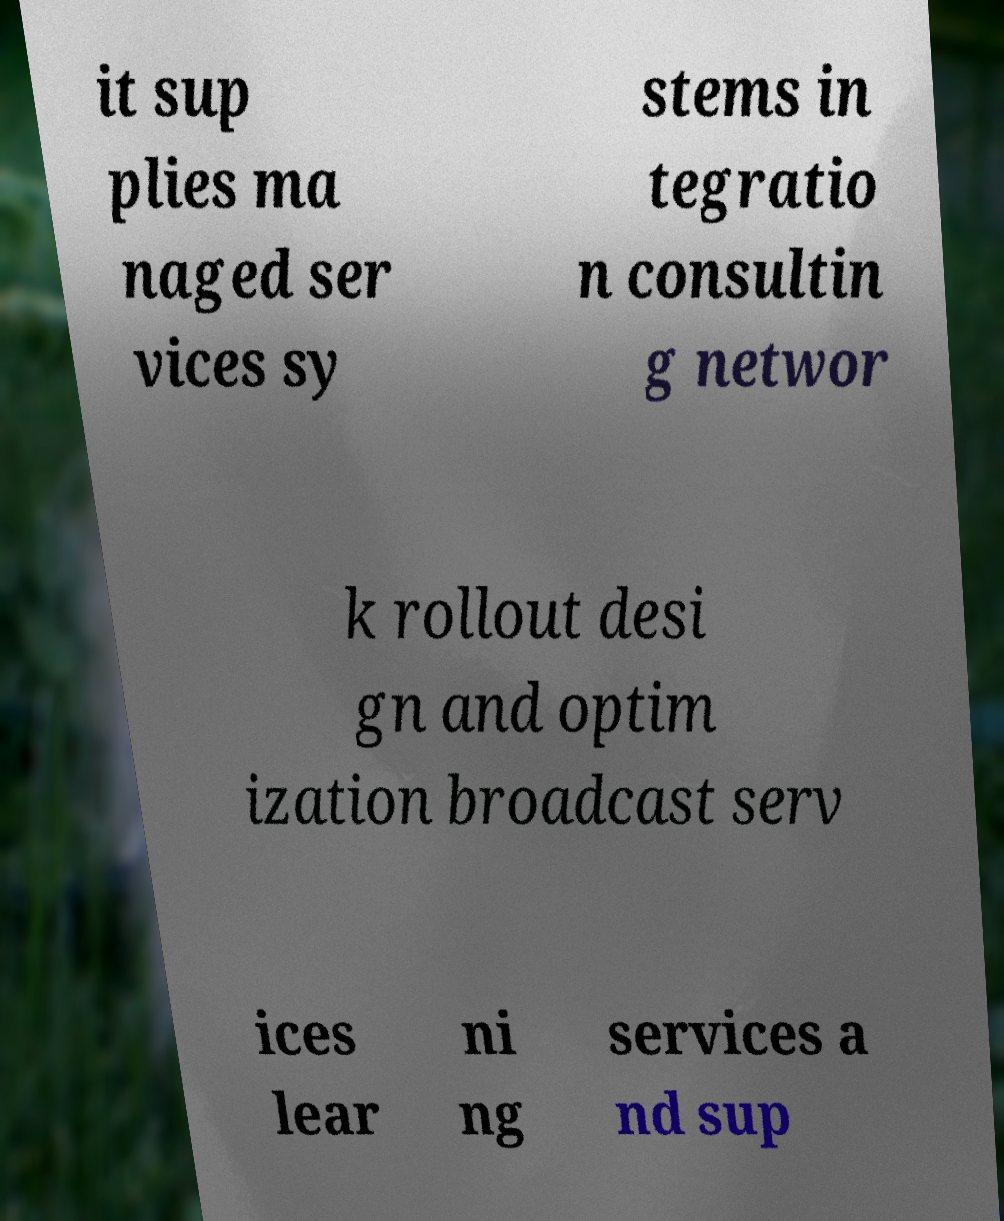Could you extract and type out the text from this image? it sup plies ma naged ser vices sy stems in tegratio n consultin g networ k rollout desi gn and optim ization broadcast serv ices lear ni ng services a nd sup 